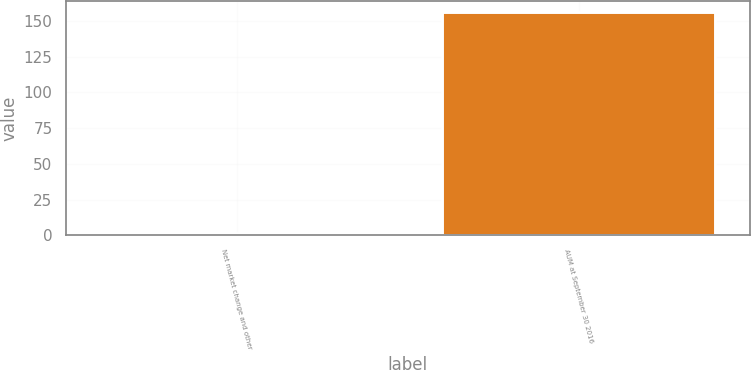Convert chart to OTSL. <chart><loc_0><loc_0><loc_500><loc_500><bar_chart><fcel>Net market change and other<fcel>AUM at September 30 2016<nl><fcel>1.9<fcel>156.2<nl></chart> 